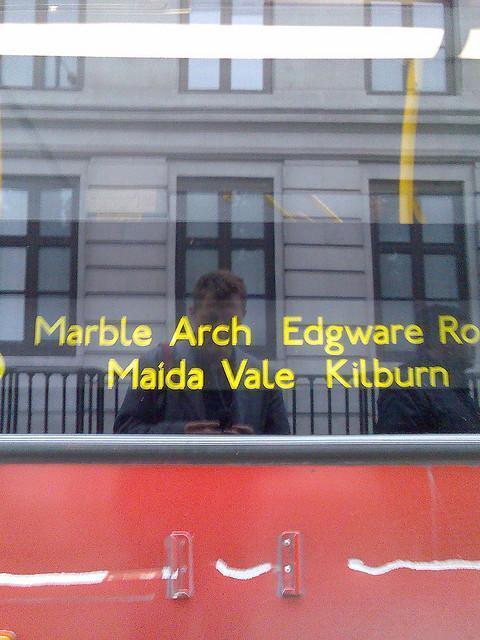How many people can be seen?
Give a very brief answer. 2. 